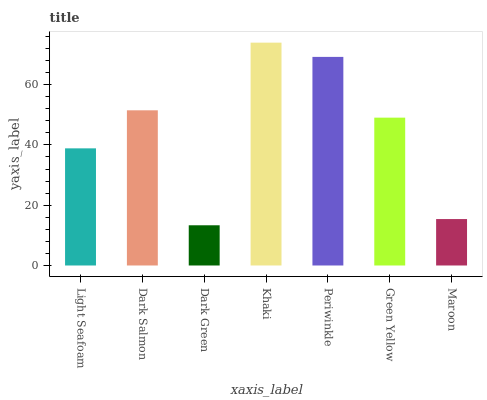Is Dark Green the minimum?
Answer yes or no. Yes. Is Khaki the maximum?
Answer yes or no. Yes. Is Dark Salmon the minimum?
Answer yes or no. No. Is Dark Salmon the maximum?
Answer yes or no. No. Is Dark Salmon greater than Light Seafoam?
Answer yes or no. Yes. Is Light Seafoam less than Dark Salmon?
Answer yes or no. Yes. Is Light Seafoam greater than Dark Salmon?
Answer yes or no. No. Is Dark Salmon less than Light Seafoam?
Answer yes or no. No. Is Green Yellow the high median?
Answer yes or no. Yes. Is Green Yellow the low median?
Answer yes or no. Yes. Is Maroon the high median?
Answer yes or no. No. Is Dark Salmon the low median?
Answer yes or no. No. 